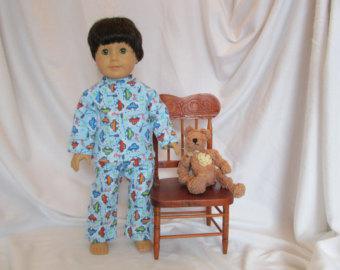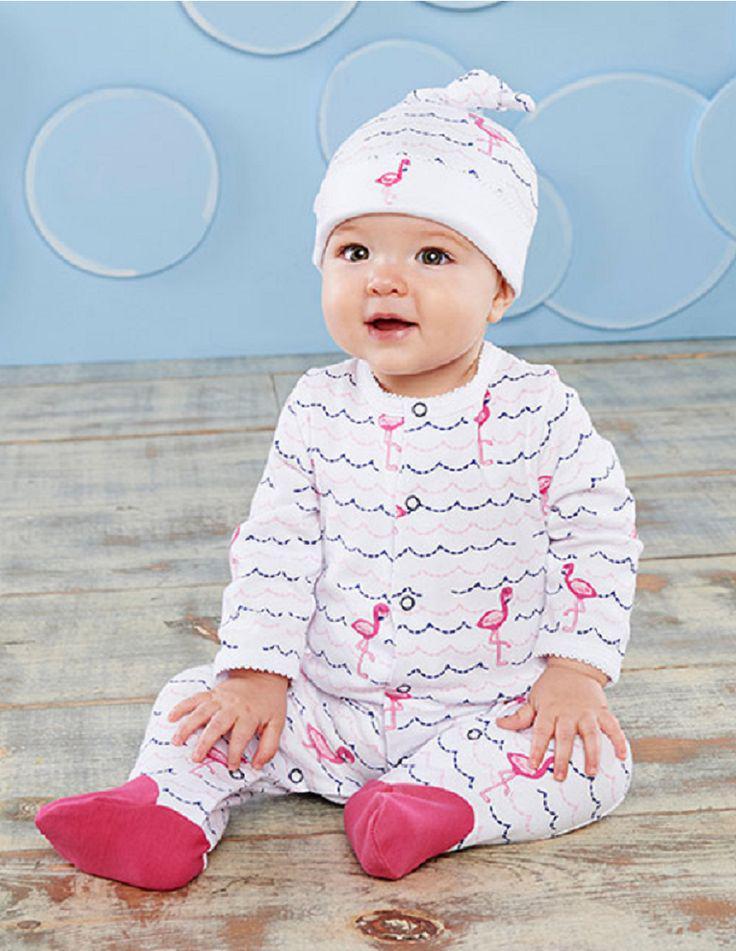The first image is the image on the left, the second image is the image on the right. Evaluate the accuracy of this statement regarding the images: "There is atleast one photo with two girls holding hands". Is it true? Answer yes or no. No. The first image is the image on the left, the second image is the image on the right. Examine the images to the left and right. Is the description "There are three children" accurate? Answer yes or no. No. 